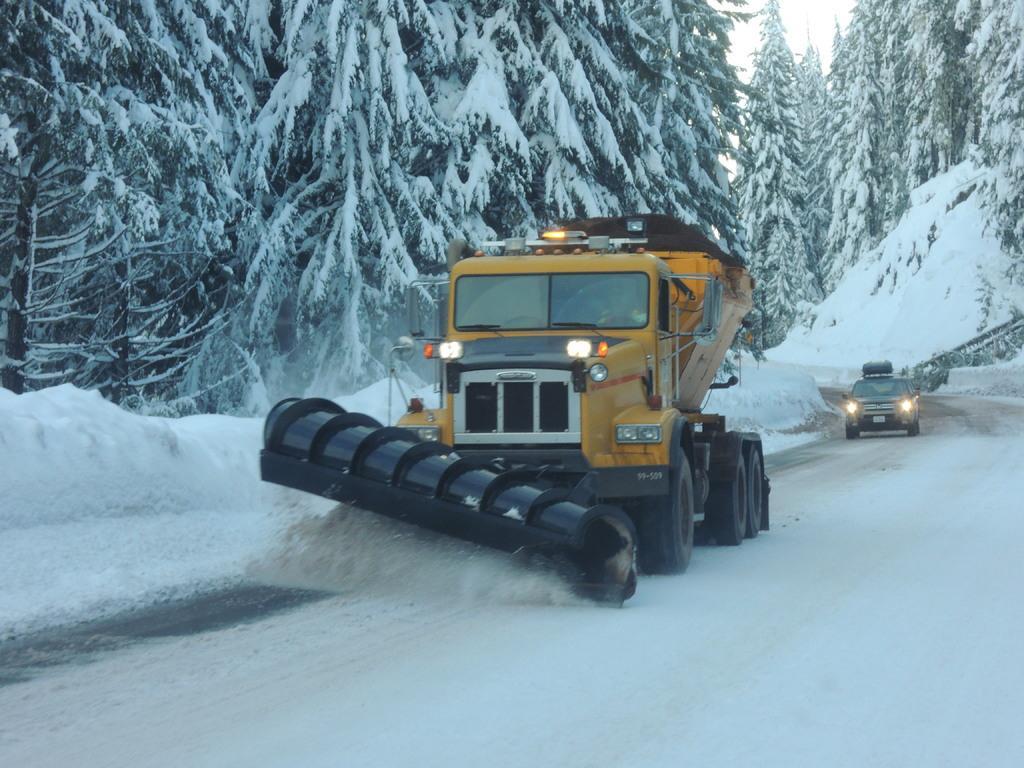How would you summarize this image in a sentence or two? In this image in the front there is snow on the ground. In the center there are vehicles moving on the road. In the background there are trees and on the trees there is snow. 